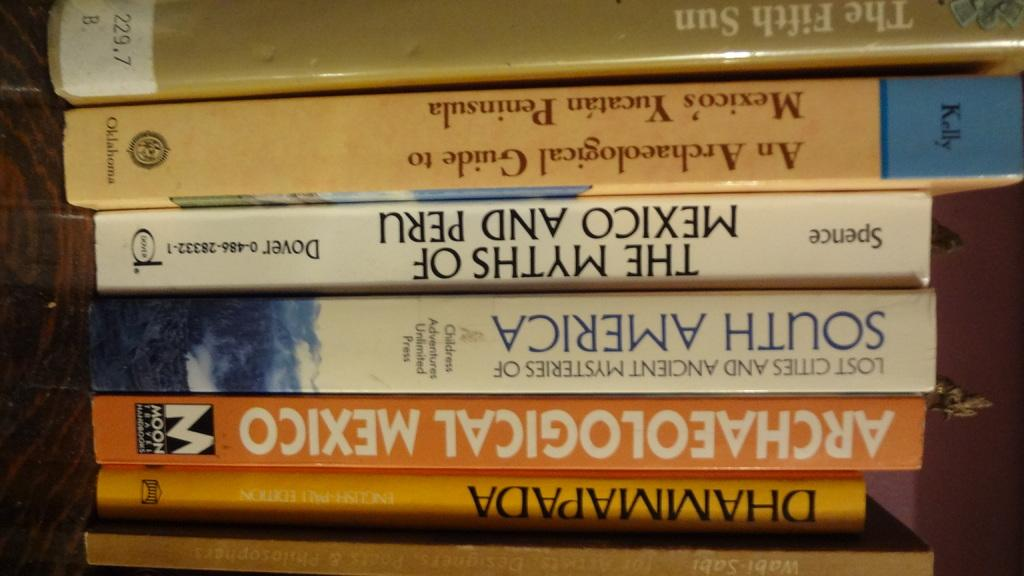<image>
Describe the image concisely. A collection of books includes the title Archaeological Mexico. 